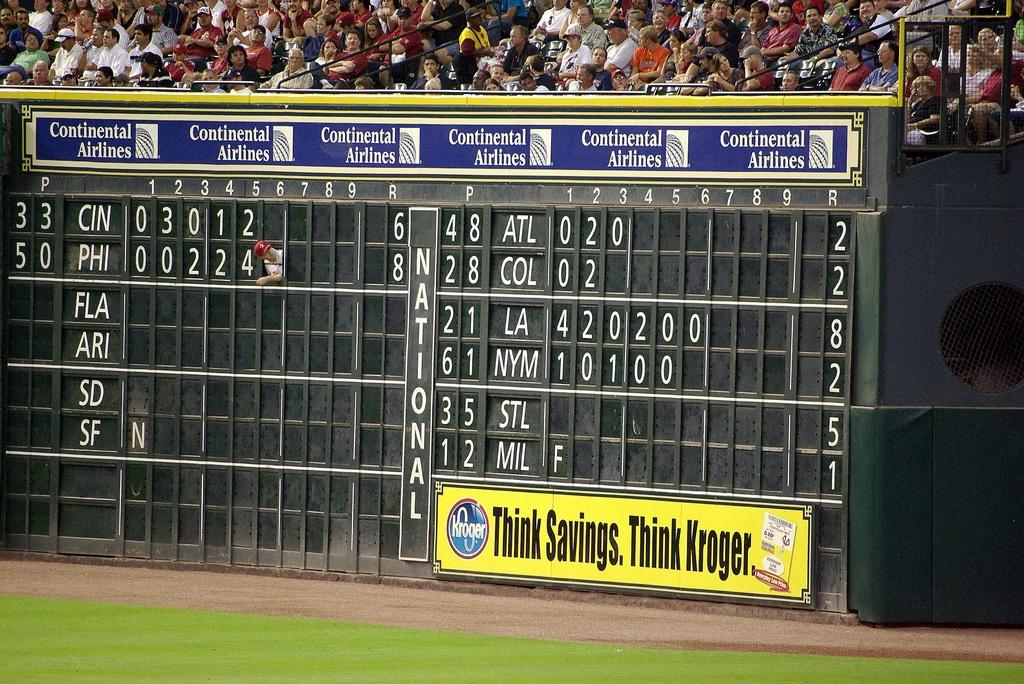<image>
Create a compact narrative representing the image presented. A scoreboard at a game that is sponsored by Kroger. 